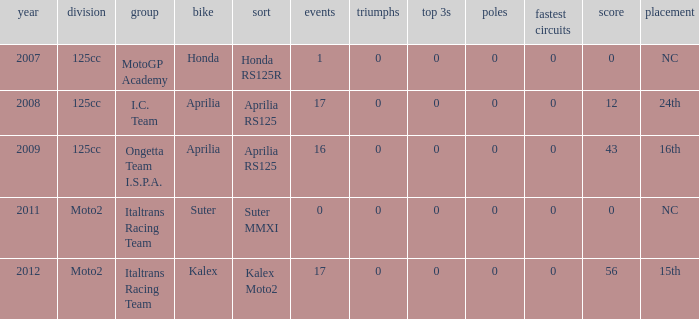What's Italtrans Racing Team's, with 0 pts, class? Moto2. 